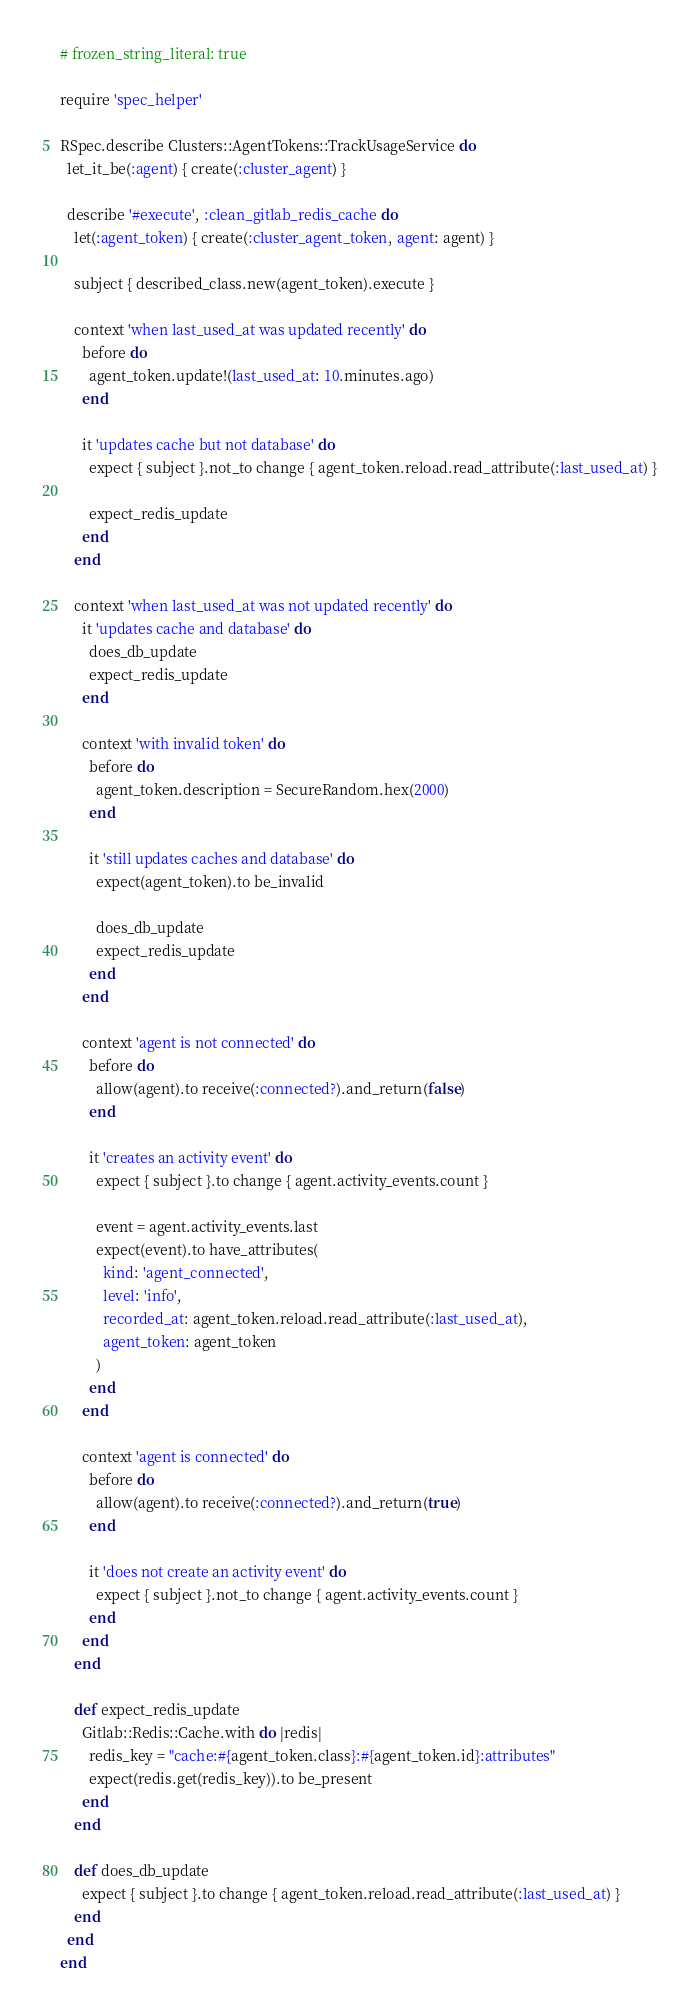<code> <loc_0><loc_0><loc_500><loc_500><_Ruby_># frozen_string_literal: true

require 'spec_helper'

RSpec.describe Clusters::AgentTokens::TrackUsageService do
  let_it_be(:agent) { create(:cluster_agent) }

  describe '#execute', :clean_gitlab_redis_cache do
    let(:agent_token) { create(:cluster_agent_token, agent: agent) }

    subject { described_class.new(agent_token).execute }

    context 'when last_used_at was updated recently' do
      before do
        agent_token.update!(last_used_at: 10.minutes.ago)
      end

      it 'updates cache but not database' do
        expect { subject }.not_to change { agent_token.reload.read_attribute(:last_used_at) }

        expect_redis_update
      end
    end

    context 'when last_used_at was not updated recently' do
      it 'updates cache and database' do
        does_db_update
        expect_redis_update
      end

      context 'with invalid token' do
        before do
          agent_token.description = SecureRandom.hex(2000)
        end

        it 'still updates caches and database' do
          expect(agent_token).to be_invalid

          does_db_update
          expect_redis_update
        end
      end

      context 'agent is not connected' do
        before do
          allow(agent).to receive(:connected?).and_return(false)
        end

        it 'creates an activity event' do
          expect { subject }.to change { agent.activity_events.count }

          event = agent.activity_events.last
          expect(event).to have_attributes(
            kind: 'agent_connected',
            level: 'info',
            recorded_at: agent_token.reload.read_attribute(:last_used_at),
            agent_token: agent_token
          )
        end
      end

      context 'agent is connected' do
        before do
          allow(agent).to receive(:connected?).and_return(true)
        end

        it 'does not create an activity event' do
          expect { subject }.not_to change { agent.activity_events.count }
        end
      end
    end

    def expect_redis_update
      Gitlab::Redis::Cache.with do |redis|
        redis_key = "cache:#{agent_token.class}:#{agent_token.id}:attributes"
        expect(redis.get(redis_key)).to be_present
      end
    end

    def does_db_update
      expect { subject }.to change { agent_token.reload.read_attribute(:last_used_at) }
    end
  end
end
</code> 